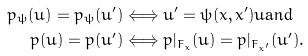<formula> <loc_0><loc_0><loc_500><loc_500>p _ { \psi } ( \bar { u } ) = p _ { \psi } ( \bar { u } ^ { \prime } ) & \Longleftrightarrow \bar { u } ^ { \prime } = \psi ( \bar { x } , \bar { x } ^ { \prime } ) \bar { u } \text {and} \\ p ( \bar { u } ) = p ( \bar { u } ^ { \prime } ) & \Longleftrightarrow p | _ { F _ { \bar { x } } } ( \bar { u } ) = p | _ { F _ { \bar { x } ^ { \prime } } } ( \bar { u } ^ { \prime } ) .</formula> 